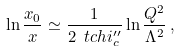Convert formula to latex. <formula><loc_0><loc_0><loc_500><loc_500>\ln \frac { x _ { 0 } } { x } \simeq \frac { 1 } { 2 \ t c h i _ { c } ^ { \prime \prime } } \ln \frac { Q ^ { 2 } } { \Lambda ^ { 2 } } \, ,</formula> 